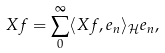<formula> <loc_0><loc_0><loc_500><loc_500>X f = \sum _ { 0 } ^ { \infty } \langle X f , e _ { n } \rangle _ { \mathcal { H } } e _ { n } ,</formula> 